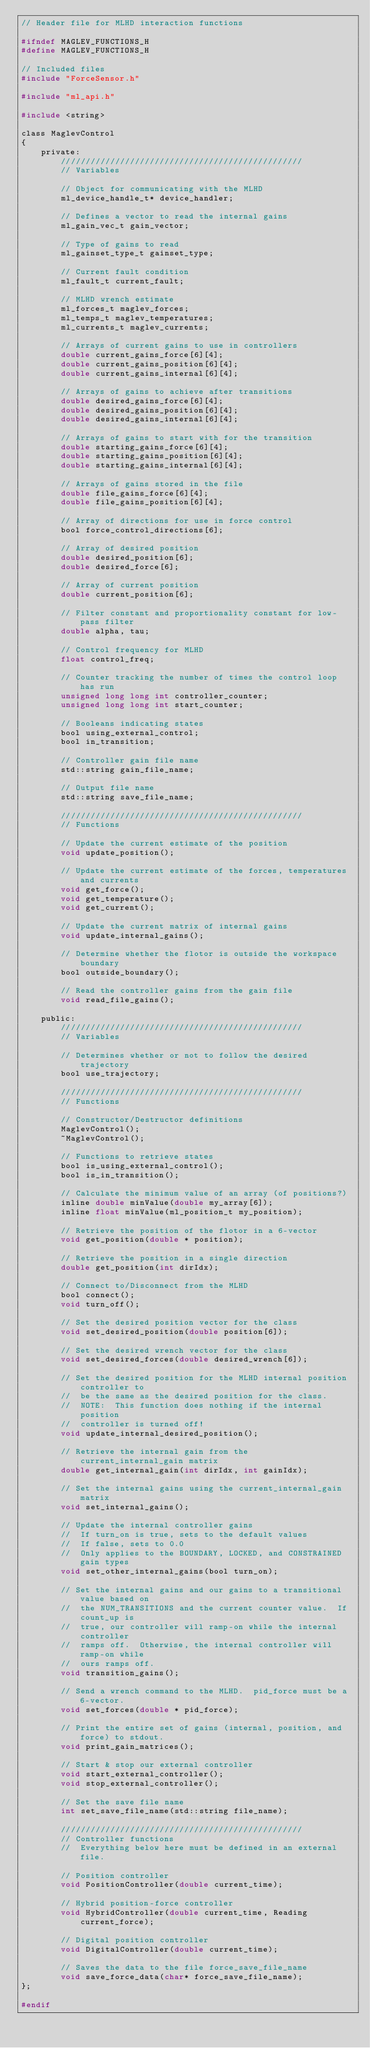Convert code to text. <code><loc_0><loc_0><loc_500><loc_500><_C_>// Header file for MLHD interaction functions

#ifndef MAGLEV_FUNCTIONS_H
#define MAGLEV_FUNCTIONS_H

// Included files
#include "ForceSensor.h"

#include "ml_api.h"

#include <string>

class MaglevControl
{
    private:
        /////////////////////////////////////////////////
        // Variables
        
        // Object for communicating with the MLHD
        ml_device_handle_t* device_handler;
        
        // Defines a vector to read the internal gains
        ml_gain_vec_t gain_vector;
        
        // Type of gains to read
        ml_gainset_type_t gainset_type;
        
        // Current fault condition
        ml_fault_t current_fault;
        
        // MLHD wrench estimate
        ml_forces_t maglev_forces;
        ml_temps_t maglev_temperatures;
        ml_currents_t maglev_currents;
        
        // Arrays of current gains to use in controllers
        double current_gains_force[6][4];
        double current_gains_position[6][4];
        double current_gains_internal[6][4];
        
        // Arrays of gains to achieve after transitions
        double desired_gains_force[6][4];
        double desired_gains_position[6][4];
        double desired_gains_internal[6][4];
        
        // Arrays of gains to start with for the transition
        double starting_gains_force[6][4];
        double starting_gains_position[6][4];
        double starting_gains_internal[6][4];
        
        // Arrays of gains stored in the file
        double file_gains_force[6][4];
        double file_gains_position[6][4];
        
        // Array of directions for use in force control
        bool force_control_directions[6];
        
        // Array of desired position
        double desired_position[6];
        double desired_force[6];
        
        // Array of current position
        double current_position[6];
        
        // Filter constant and proportionality constant for low-pass filter
        double alpha, tau;
        
        // Control frequency for MLHD
        float control_freq;
        
        // Counter tracking the number of times the control loop has run
        unsigned long long int controller_counter;
        unsigned long long int start_counter;
        
        // Booleans indicating states
        bool using_external_control;
        bool in_transition;
        
        // Controller gain file name
        std::string gain_file_name;
        
        // Output file name
        std::string save_file_name;
        
        /////////////////////////////////////////////////
        // Functions
        
        // Update the current estimate of the position
        void update_position();
        
        // Update the current estimate of the forces, temperatures and currents
        void get_force();
        void get_temperature();
        void get_current();
        
        // Update the current matrix of internal gains
        void update_internal_gains();
        
        // Determine whether the flotor is outside the workspace boundary
        bool outside_boundary();
        
        // Read the controller gains from the gain file
        void read_file_gains();
        
    public:
        /////////////////////////////////////////////////
        // Variables
        
        // Determines whether or not to follow the desired trajectory
        bool use_trajectory;
        
        /////////////////////////////////////////////////
        // Functions
        
        // Constructor/Destructor definitions
        MaglevControl();
        ~MaglevControl();
        
        // Functions to retrieve states
        bool is_using_external_control();
        bool is_in_transition();
        
        // Calculate the minimum value of an array (of positions?)
        inline double minValue(double my_array[6]);
        inline float minValue(ml_position_t my_position);
        
        // Retrieve the position of the flotor in a 6-vector
        void get_position(double * position);
        
        // Retrieve the position in a single direction
        double get_position(int dirIdx);
        
        // Connect to/Disconnect from the MLHD
        bool connect();
        void turn_off();
        
        // Set the desired position vector for the class
        void set_desired_position(double position[6]);
        
        // Set the desired wrench vector for the class
        void set_desired_forces(double desired_wrench[6]);
        
        // Set the desired position for the MLHD internal position controller to
        //  be the same as the desired position for the class.
        //  NOTE:  This function does nothing if the internal position
        //  controller is turned off!
        void update_internal_desired_position();
        
        // Retrieve the internal gain from the current_internal_gain matrix
        double get_internal_gain(int dirIdx, int gainIdx);
        
        // Set the internal gains using the current_internal_gain matrix
        void set_internal_gains();
        
        // Update the internal controller gains
        //  If turn_on is true, sets to the default values
        //  If false, sets to 0.0
        //  Only applies to the BOUNDARY, LOCKED, and CONSTRAINED gain types
        void set_other_internal_gains(bool turn_on);
        
        // Set the internal gains and our gains to a transitional value based on
        //  the NUM_TRANSITIONS and the current counter value.  If count_up is
        //  true, our controller will ramp-on while the internal controller
        //  ramps off.  Otherwise, the internal controller will ramp-on while
        //  ours ramps off.
        void transition_gains();
        
        // Send a wrench command to the MLHD.  pid_force must be a 6-vector.
        void set_forces(double * pid_force);
        
        // Print the entire set of gains (internal, position, and force) to stdout.
        void print_gain_matrices();
        
        // Start & stop our external controller
        void start_external_controller();
        void stop_external_controller();
        
        // Set the save file name
        int set_save_file_name(std::string file_name);
        
        /////////////////////////////////////////////////
        // Controller functions
        //  Everything below here must be defined in an external file.
        
        // Position controller
        void PositionController(double current_time);
        
        // Hybrid position-force controller
        void HybridController(double current_time, Reading current_force);
        
        // Digital position controller
        void DigitalController(double current_time);
        
        // Saves the data to the file force_save_file_name
        void save_force_data(char* force_save_file_name);
};

#endif
</code> 